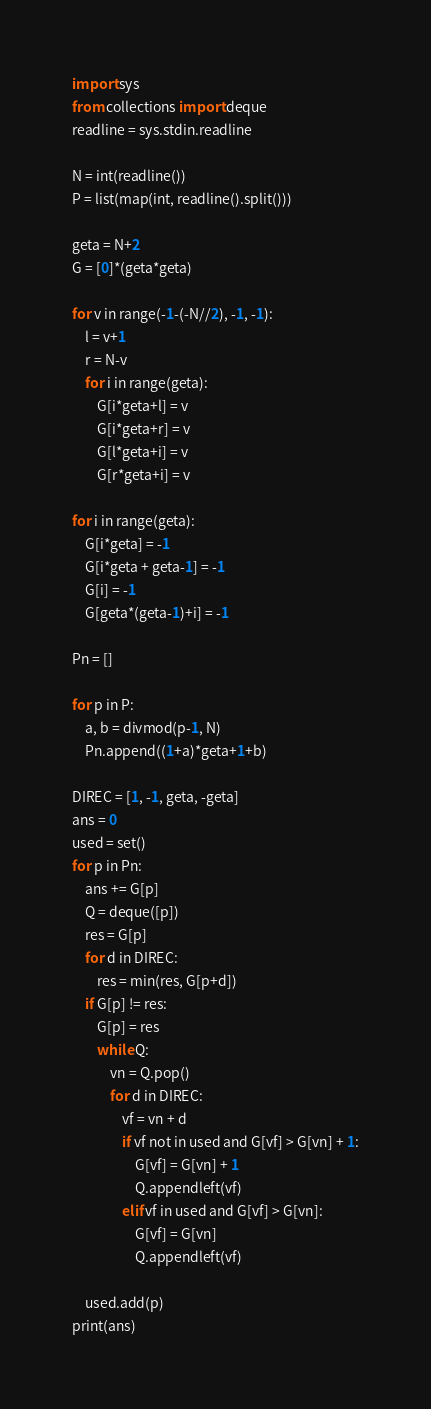<code> <loc_0><loc_0><loc_500><loc_500><_Python_>import sys
from collections import deque
readline = sys.stdin.readline

N = int(readline())
P = list(map(int, readline().split()))

geta = N+2
G = [0]*(geta*geta)

for v in range(-1-(-N//2), -1, -1):
    l = v+1
    r = N-v
    for i in range(geta):
        G[i*geta+l] = v
        G[i*geta+r] = v
        G[l*geta+i] = v
        G[r*geta+i] = v

for i in range(geta):
    G[i*geta] = -1
    G[i*geta + geta-1] = -1
    G[i] = -1
    G[geta*(geta-1)+i] = -1

Pn = []

for p in P:
    a, b = divmod(p-1, N)
    Pn.append((1+a)*geta+1+b)

DIREC = [1, -1, geta, -geta]
ans = 0
used = set()
for p in Pn:
    ans += G[p]
    Q = deque([p])
    res = G[p]
    for d in DIREC:
        res = min(res, G[p+d])
    if G[p] != res:
        G[p] = res
        while Q:
            vn = Q.pop()
            for d in DIREC:
                vf = vn + d
                if vf not in used and G[vf] > G[vn] + 1:
                    G[vf] = G[vn] + 1
                    Q.appendleft(vf)
                elif vf in used and G[vf] > G[vn]:
                    G[vf] = G[vn]
                    Q.appendleft(vf)
                    
    used.add(p)
print(ans)</code> 